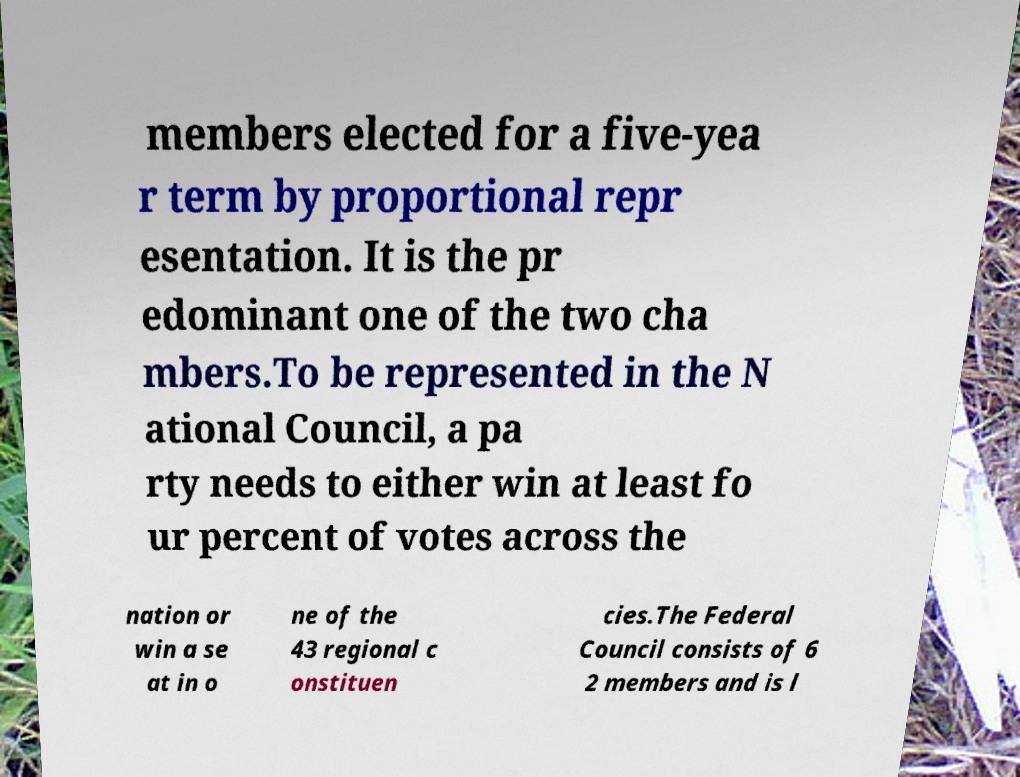I need the written content from this picture converted into text. Can you do that? members elected for a five-yea r term by proportional repr esentation. It is the pr edominant one of the two cha mbers.To be represented in the N ational Council, a pa rty needs to either win at least fo ur percent of votes across the nation or win a se at in o ne of the 43 regional c onstituen cies.The Federal Council consists of 6 2 members and is l 